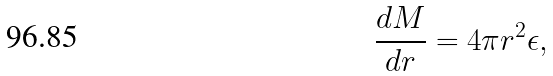Convert formula to latex. <formula><loc_0><loc_0><loc_500><loc_500>\frac { d M } { d r } = 4 \pi r ^ { 2 } \epsilon ,</formula> 